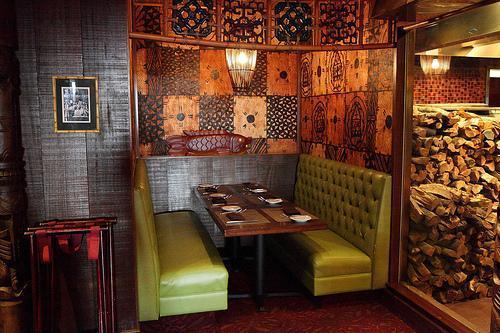How many tables?
Give a very brief answer. 1. 